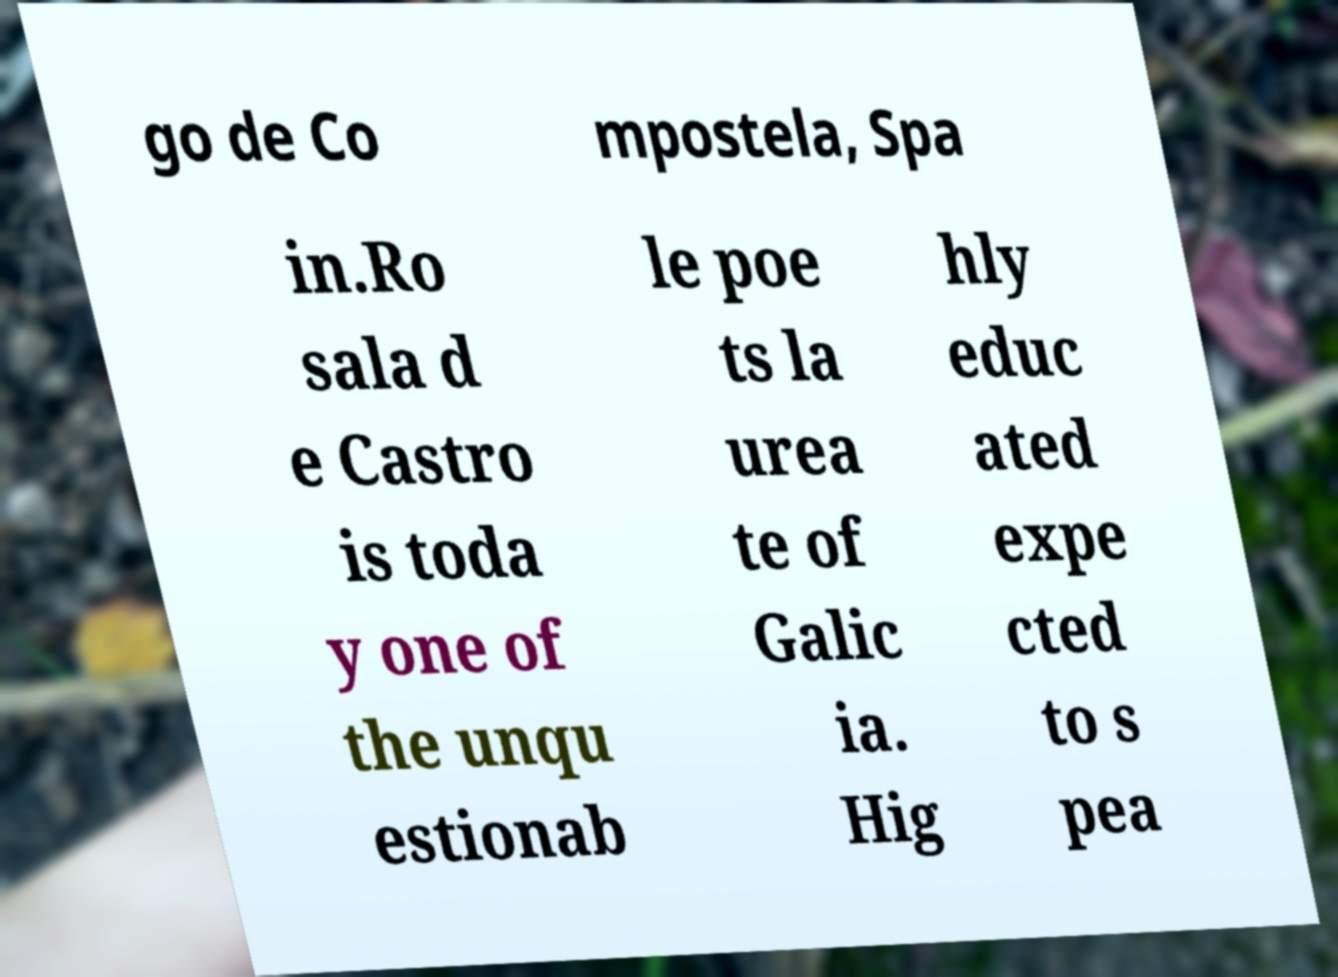I need the written content from this picture converted into text. Can you do that? go de Co mpostela, Spa in.Ro sala d e Castro is toda y one of the unqu estionab le poe ts la urea te of Galic ia. Hig hly educ ated expe cted to s pea 